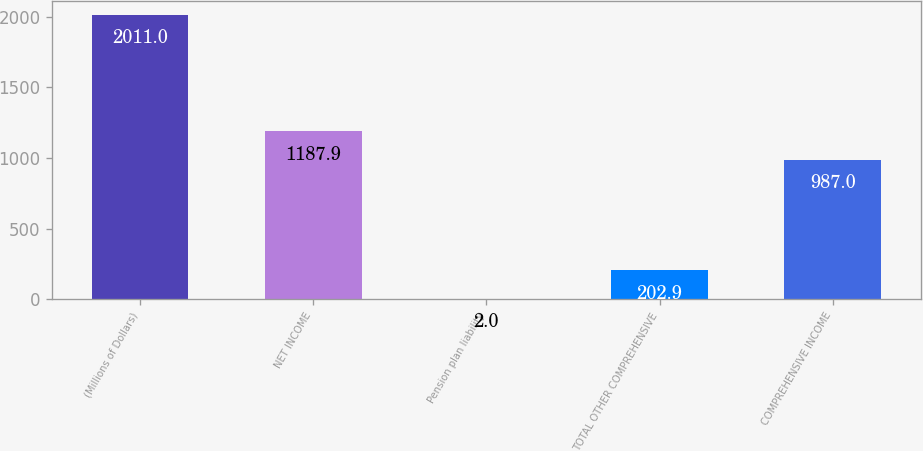Convert chart. <chart><loc_0><loc_0><loc_500><loc_500><bar_chart><fcel>(Millions of Dollars)<fcel>NET INCOME<fcel>Pension plan liability<fcel>TOTAL OTHER COMPREHENSIVE<fcel>COMPREHENSIVE INCOME<nl><fcel>2011<fcel>1187.9<fcel>2<fcel>202.9<fcel>987<nl></chart> 